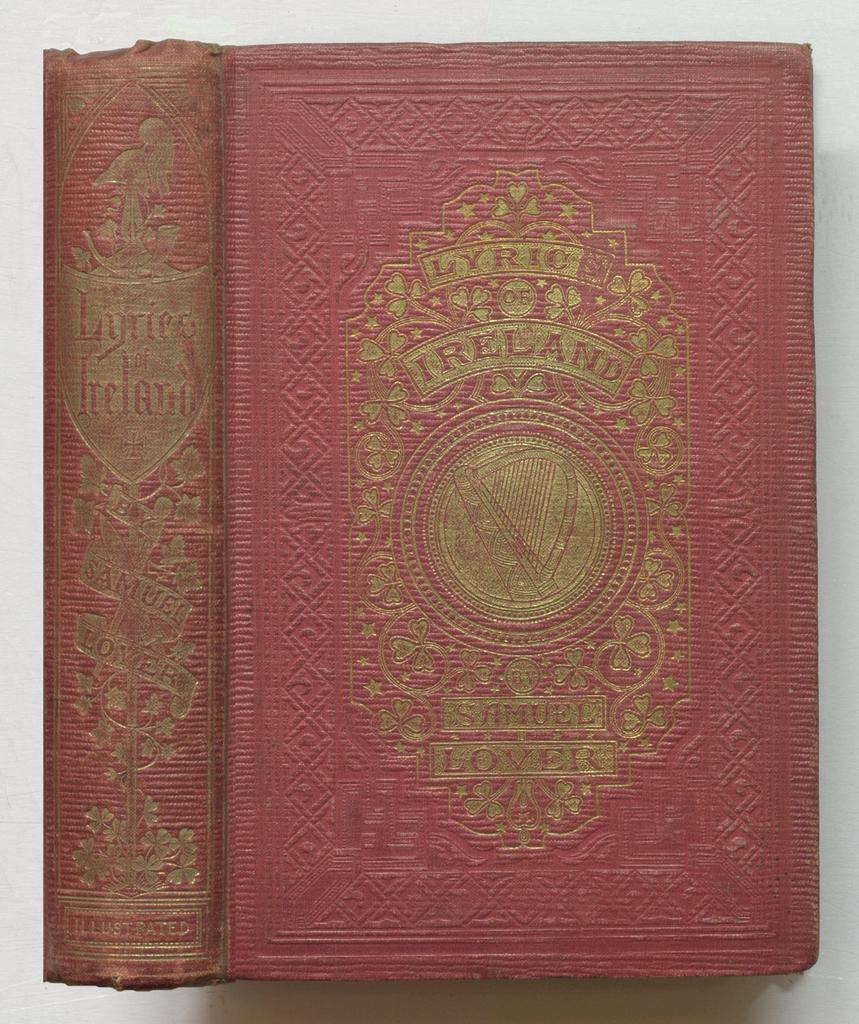<image>
Present a compact description of the photo's key features. The book Lyric of Ireland was written by Samuel Lover. 